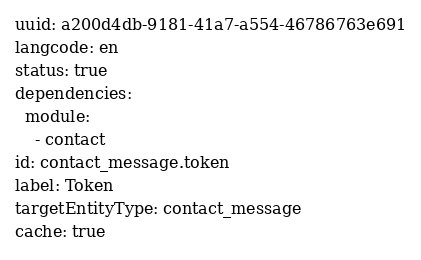<code> <loc_0><loc_0><loc_500><loc_500><_YAML_>uuid: a200d4db-9181-41a7-a554-46786763e691
langcode: en
status: true
dependencies:
  module:
    - contact
id: contact_message.token
label: Token
targetEntityType: contact_message
cache: true
</code> 